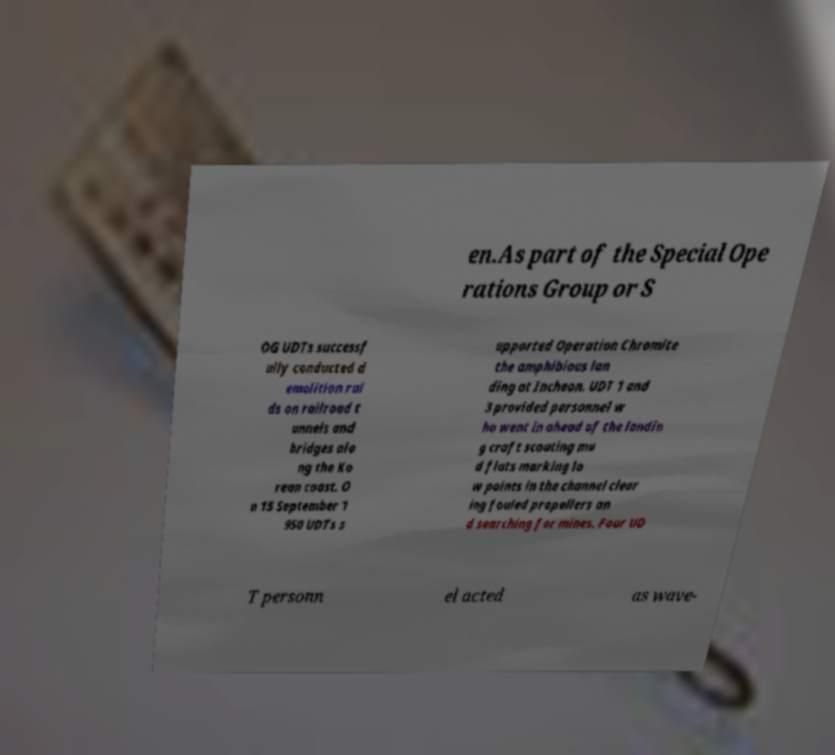What messages or text are displayed in this image? I need them in a readable, typed format. en.As part of the Special Ope rations Group or S OG UDTs successf ully conducted d emolition rai ds on railroad t unnels and bridges alo ng the Ko rean coast. O n 15 September 1 950 UDTs s upported Operation Chromite the amphibious lan ding at Incheon. UDT 1 and 3 provided personnel w ho went in ahead of the landin g craft scouting mu d flats marking lo w points in the channel clear ing fouled propellers an d searching for mines. Four UD T personn el acted as wave- 